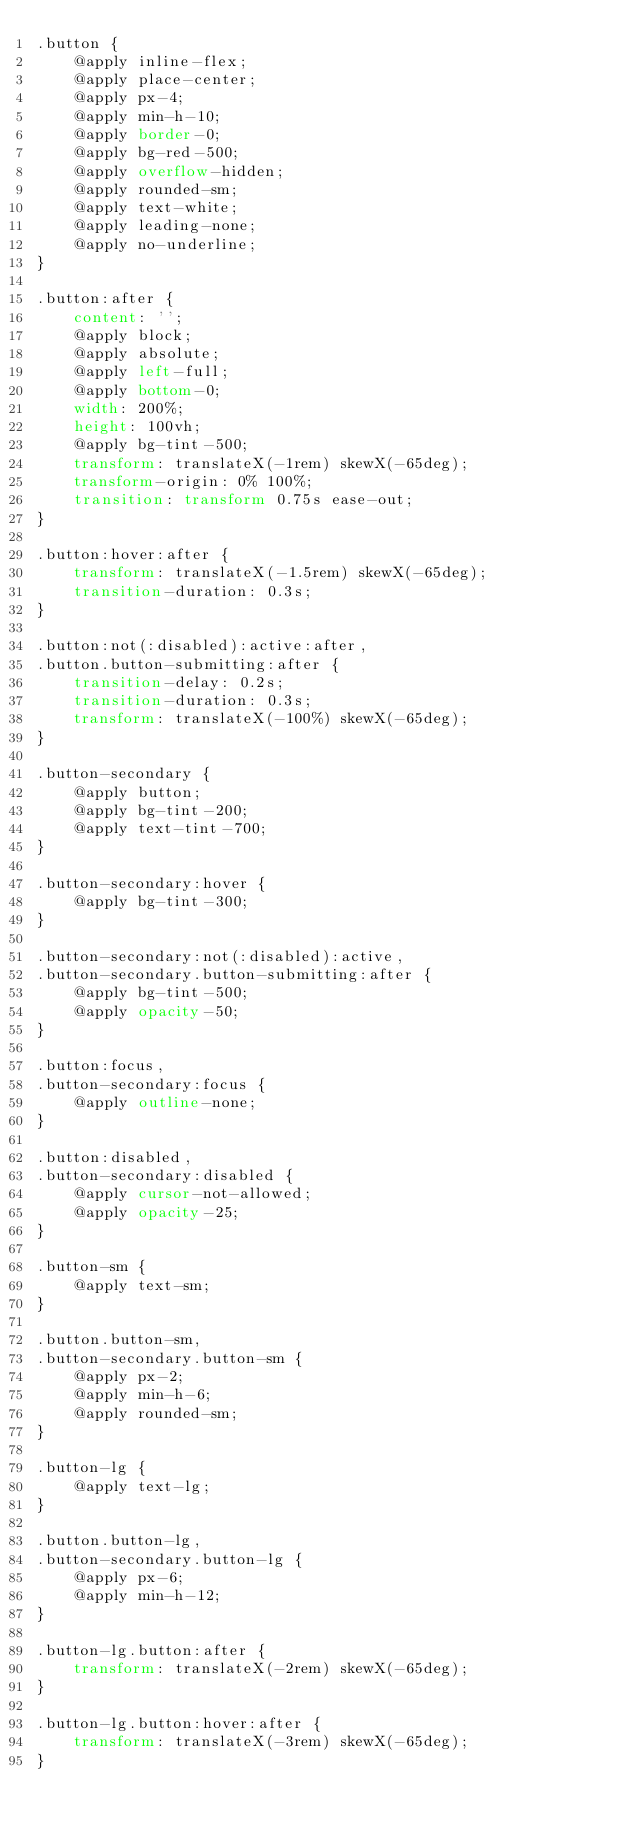<code> <loc_0><loc_0><loc_500><loc_500><_CSS_>.button {
    @apply inline-flex;
    @apply place-center;
    @apply px-4;
    @apply min-h-10;
    @apply border-0;
    @apply bg-red-500;
    @apply overflow-hidden;
    @apply rounded-sm;
    @apply text-white;
    @apply leading-none;
    @apply no-underline;
}

.button:after {
    content: '';
    @apply block;
    @apply absolute;
    @apply left-full;
    @apply bottom-0;
    width: 200%;
    height: 100vh;
    @apply bg-tint-500;
    transform: translateX(-1rem) skewX(-65deg);
    transform-origin: 0% 100%;
    transition: transform 0.75s ease-out;
}

.button:hover:after {
    transform: translateX(-1.5rem) skewX(-65deg);
    transition-duration: 0.3s;
}

.button:not(:disabled):active:after,
.button.button-submitting:after {
    transition-delay: 0.2s;
    transition-duration: 0.3s;
    transform: translateX(-100%) skewX(-65deg);
}

.button-secondary {
    @apply button;
    @apply bg-tint-200;
    @apply text-tint-700;
}

.button-secondary:hover {
    @apply bg-tint-300;
}

.button-secondary:not(:disabled):active,
.button-secondary.button-submitting:after {
    @apply bg-tint-500;
    @apply opacity-50;
}

.button:focus,
.button-secondary:focus {
    @apply outline-none;
}

.button:disabled,
.button-secondary:disabled {
    @apply cursor-not-allowed;
    @apply opacity-25;
}

.button-sm {
    @apply text-sm;
}

.button.button-sm,
.button-secondary.button-sm {
    @apply px-2;
    @apply min-h-6;
    @apply rounded-sm;
}

.button-lg {
    @apply text-lg;
}

.button.button-lg,
.button-secondary.button-lg {
    @apply px-6;
    @apply min-h-12;
}

.button-lg.button:after {
    transform: translateX(-2rem) skewX(-65deg);
}

.button-lg.button:hover:after {
    transform: translateX(-3rem) skewX(-65deg);
}
</code> 